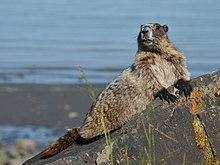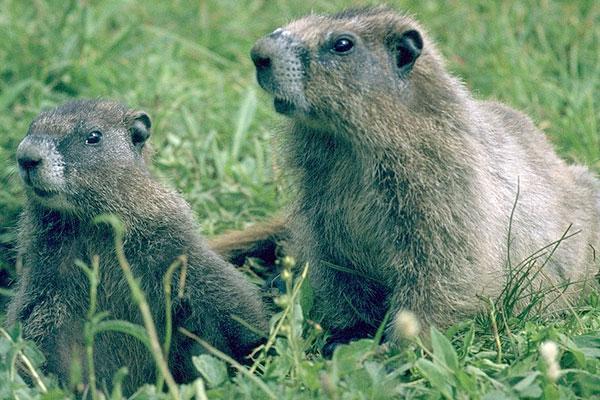The first image is the image on the left, the second image is the image on the right. Examine the images to the left and right. Is the description "The left and right image contains the same number of groundhogs on stone.." accurate? Answer yes or no. No. The first image is the image on the left, the second image is the image on the right. Considering the images on both sides, is "There are two marmots on rocks." valid? Answer yes or no. No. 